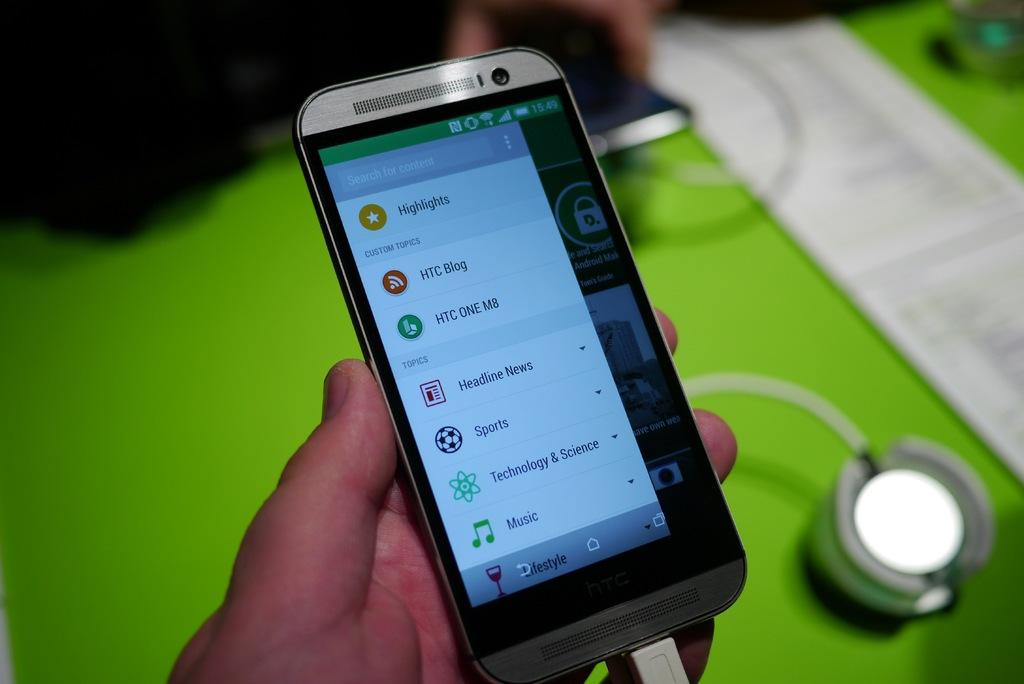<image>
Render a clear and concise summary of the photo. A person is holding a silver phone that says Highlights. 